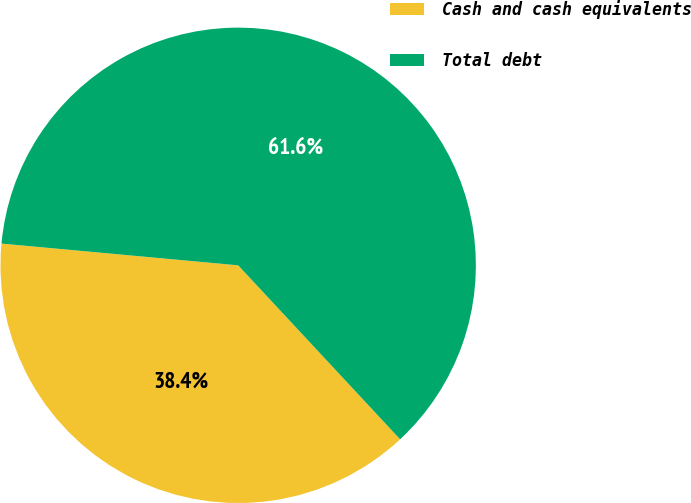Convert chart. <chart><loc_0><loc_0><loc_500><loc_500><pie_chart><fcel>Cash and cash equivalents<fcel>Total debt<nl><fcel>38.39%<fcel>61.61%<nl></chart> 